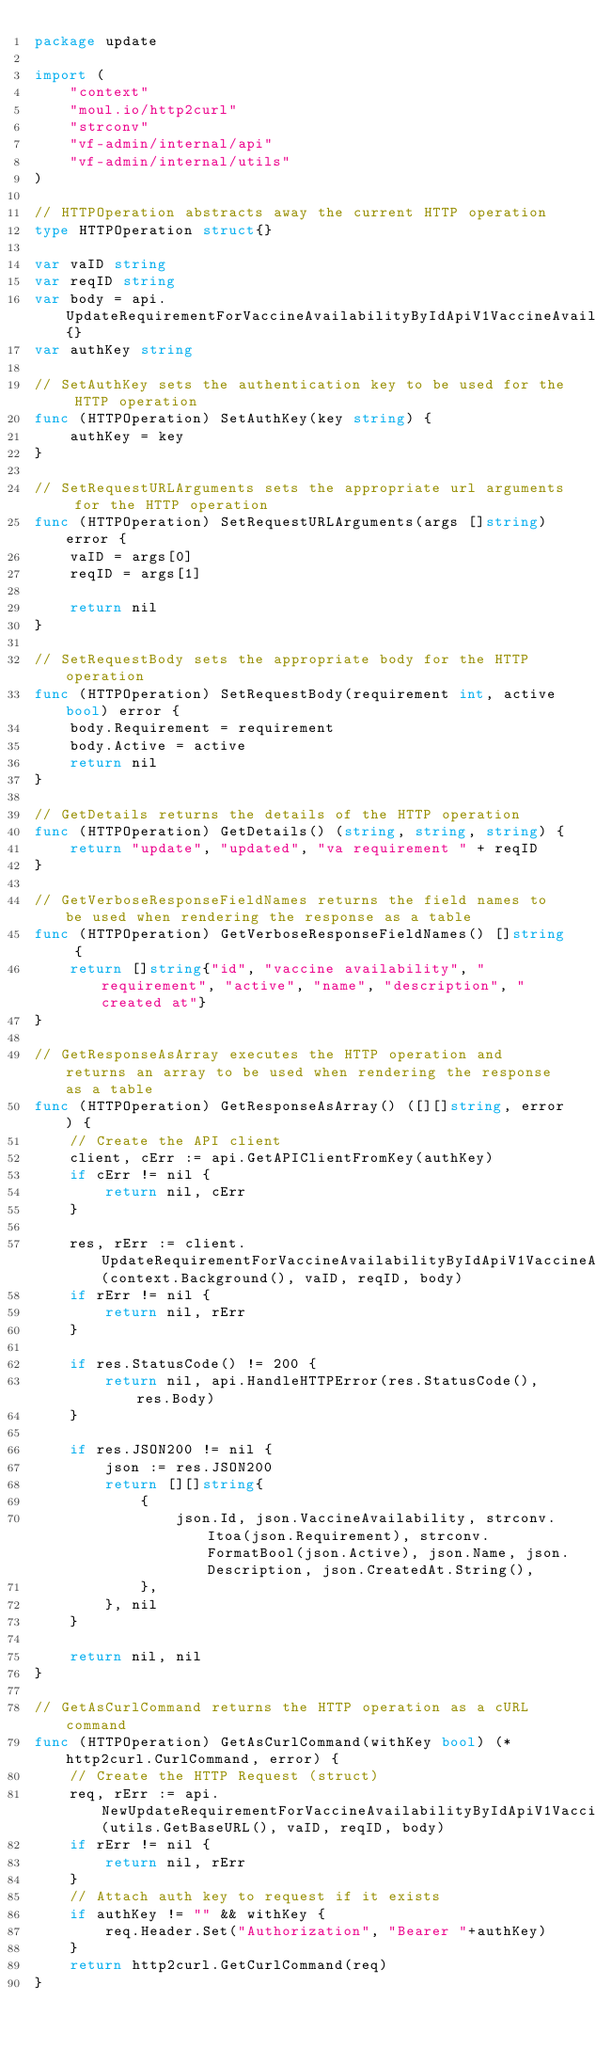<code> <loc_0><loc_0><loc_500><loc_500><_Go_>package update

import (
	"context"
	"moul.io/http2curl"
	"strconv"
	"vf-admin/internal/api"
	"vf-admin/internal/utils"
)

// HTTPOperation abstracts away the current HTTP operation
type HTTPOperation struct{}

var vaID string
var reqID string
var body = api.UpdateRequirementForVaccineAvailabilityByIdApiV1VaccineAvailabilityVaccineAvailabilityIdRequirementsRequirementIdPutJSONRequestBody{}
var authKey string

// SetAuthKey sets the authentication key to be used for the HTTP operation
func (HTTPOperation) SetAuthKey(key string) {
	authKey = key
}

// SetRequestURLArguments sets the appropriate url arguments for the HTTP operation
func (HTTPOperation) SetRequestURLArguments(args []string) error {
	vaID = args[0]
	reqID = args[1]

	return nil
}

// SetRequestBody sets the appropriate body for the HTTP operation
func (HTTPOperation) SetRequestBody(requirement int, active bool) error {
	body.Requirement = requirement
	body.Active = active
	return nil
}

// GetDetails returns the details of the HTTP operation
func (HTTPOperation) GetDetails() (string, string, string) {
	return "update", "updated", "va requirement " + reqID
}

// GetVerboseResponseFieldNames returns the field names to be used when rendering the response as a table
func (HTTPOperation) GetVerboseResponseFieldNames() []string {
	return []string{"id", "vaccine availability", "requirement", "active", "name", "description", "created at"}
}

// GetResponseAsArray executes the HTTP operation and returns an array to be used when rendering the response as a table
func (HTTPOperation) GetResponseAsArray() ([][]string, error) {
	// Create the API client
	client, cErr := api.GetAPIClientFromKey(authKey)
	if cErr != nil {
		return nil, cErr
	}

	res, rErr := client.UpdateRequirementForVaccineAvailabilityByIdApiV1VaccineAvailabilityVaccineAvailabilityIdRequirementsRequirementIdPutWithResponse(context.Background(), vaID, reqID, body)
	if rErr != nil {
		return nil, rErr
	}

	if res.StatusCode() != 200 {
		return nil, api.HandleHTTPError(res.StatusCode(), res.Body)
	}

	if res.JSON200 != nil {
		json := res.JSON200
		return [][]string{
			{
				json.Id, json.VaccineAvailability, strconv.Itoa(json.Requirement), strconv.FormatBool(json.Active), json.Name, json.Description, json.CreatedAt.String(),
			},
		}, nil
	}

	return nil, nil
}

// GetAsCurlCommand returns the HTTP operation as a cURL command
func (HTTPOperation) GetAsCurlCommand(withKey bool) (*http2curl.CurlCommand, error) {
	// Create the HTTP Request (struct)
	req, rErr := api.NewUpdateRequirementForVaccineAvailabilityByIdApiV1VaccineAvailabilityVaccineAvailabilityIdRequirementsRequirementIdPutRequest(utils.GetBaseURL(), vaID, reqID, body)
	if rErr != nil {
		return nil, rErr
	}
	// Attach auth key to request if it exists
	if authKey != "" && withKey {
		req.Header.Set("Authorization", "Bearer "+authKey)
	}
	return http2curl.GetCurlCommand(req)
}
</code> 